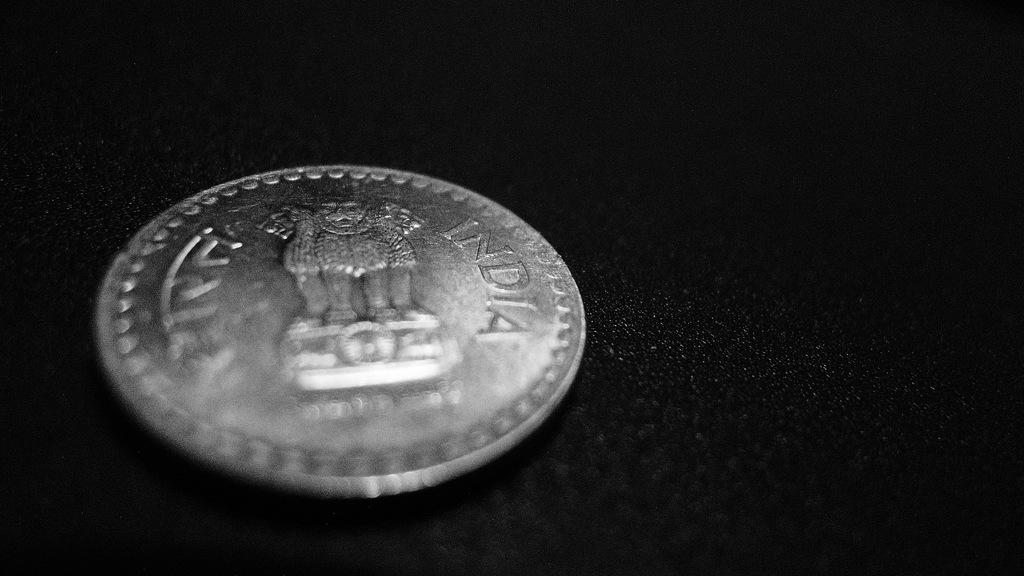<image>
Relay a brief, clear account of the picture shown. The silver coin sitting on the black background is from India. 